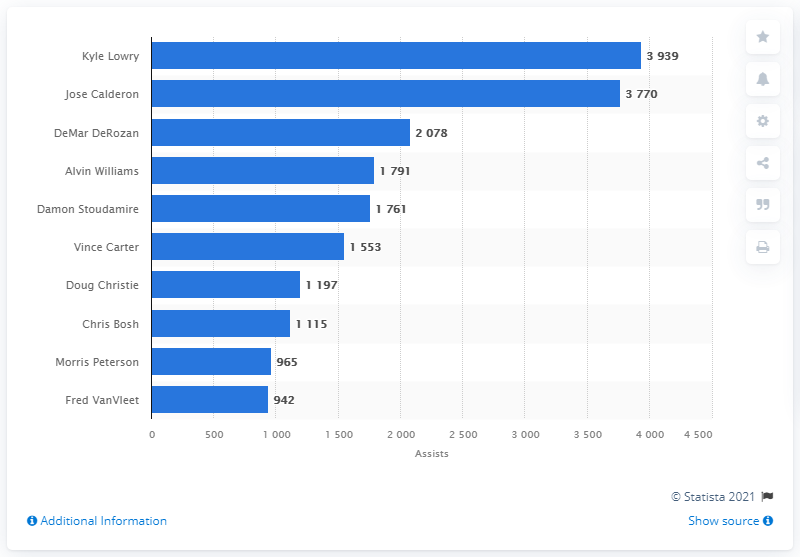Give some essential details in this illustration. Kyle Lowry is the career assists leader of the Toronto Raptors. 